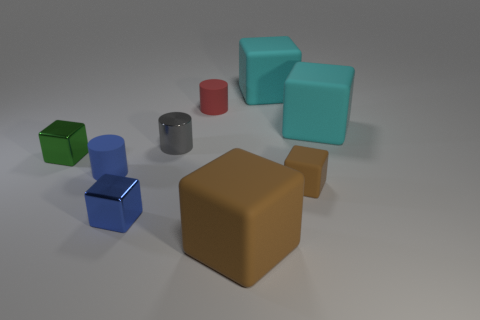Subtract 1 blocks. How many blocks are left? 5 Subtract all blue blocks. How many blocks are left? 5 Subtract all cyan blocks. How many blocks are left? 4 Subtract all green cubes. Subtract all yellow cylinders. How many cubes are left? 5 Add 1 blue cubes. How many objects exist? 10 Subtract all blocks. How many objects are left? 3 Add 9 big brown blocks. How many big brown blocks exist? 10 Subtract 1 blue cylinders. How many objects are left? 8 Subtract all brown rubber things. Subtract all green cubes. How many objects are left? 6 Add 4 small metallic blocks. How many small metallic blocks are left? 6 